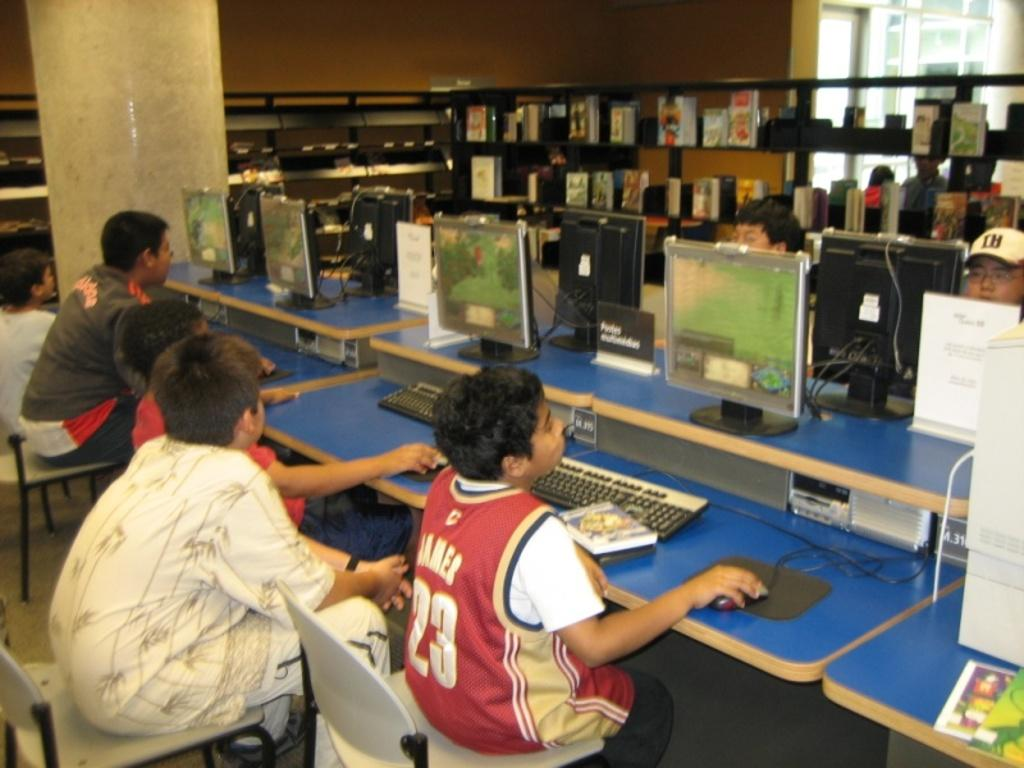<image>
Summarize the visual content of the image. A boy in a number 23 jersey works at a computer. 